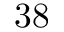Convert formula to latex. <formula><loc_0><loc_0><loc_500><loc_500>3 8</formula> 